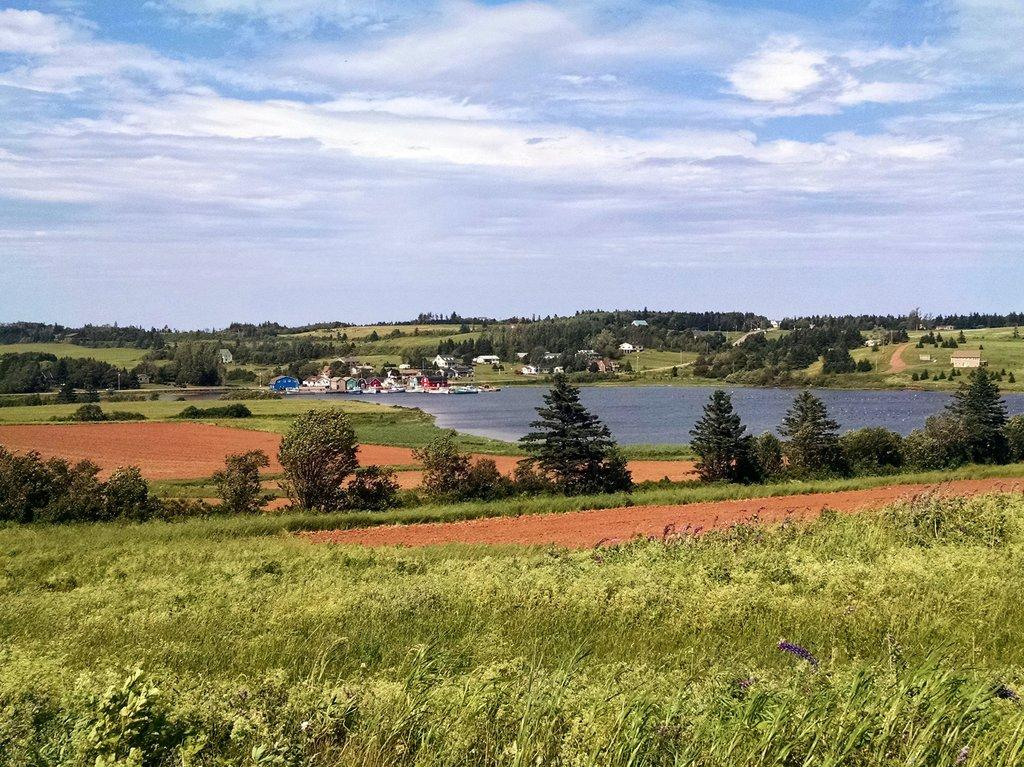What types of vegetation can be seen in the image? There are plants and trees in the image. What can be seen in the background of the image? There is water and houses visible in the background of the image. How many thumbs can be seen in the image? There are no thumbs visible in the image. What type of waves can be seen in the image? There are no waves present in the image. 